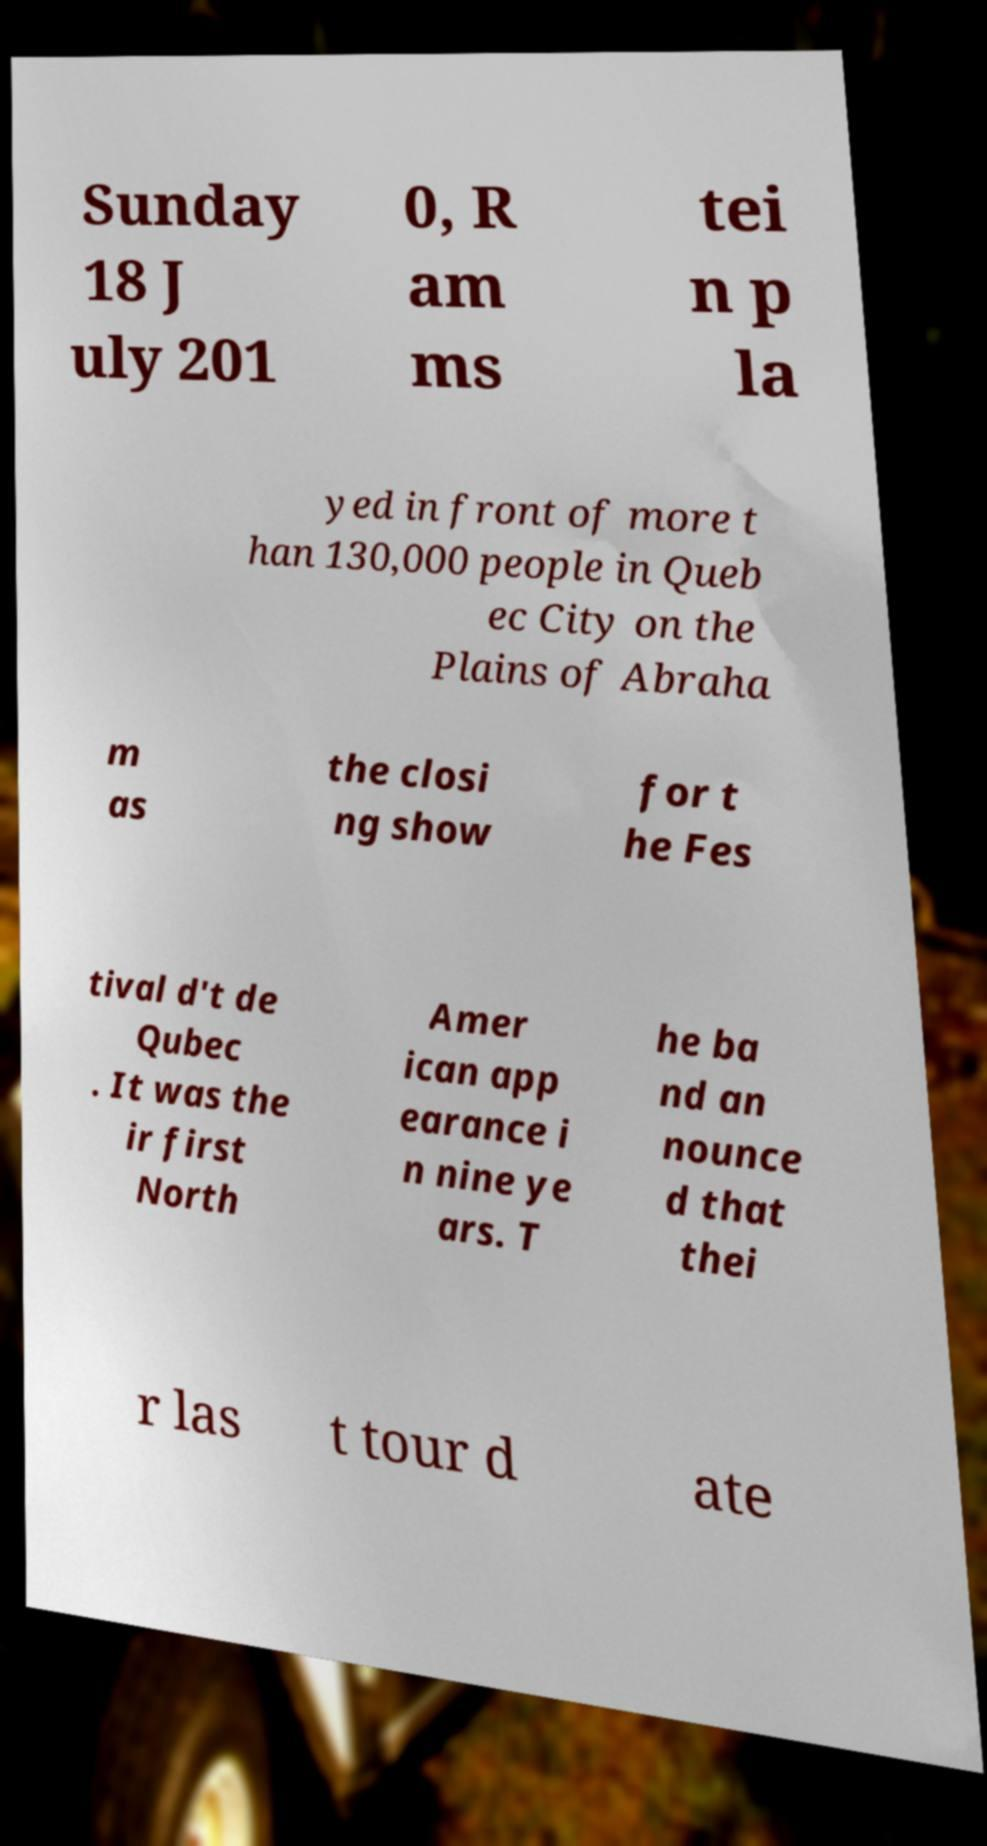Could you assist in decoding the text presented in this image and type it out clearly? Sunday 18 J uly 201 0, R am ms tei n p la yed in front of more t han 130,000 people in Queb ec City on the Plains of Abraha m as the closi ng show for t he Fes tival d't de Qubec . It was the ir first North Amer ican app earance i n nine ye ars. T he ba nd an nounce d that thei r las t tour d ate 